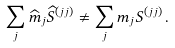<formula> <loc_0><loc_0><loc_500><loc_500>\sum _ { j } \widehat { m } _ { j } \widehat { S } ^ { ( j j ) } \ne \sum _ { j } m _ { j } S ^ { ( j j ) } \, .</formula> 